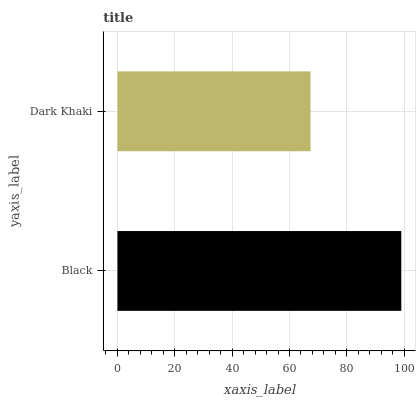Is Dark Khaki the minimum?
Answer yes or no. Yes. Is Black the maximum?
Answer yes or no. Yes. Is Dark Khaki the maximum?
Answer yes or no. No. Is Black greater than Dark Khaki?
Answer yes or no. Yes. Is Dark Khaki less than Black?
Answer yes or no. Yes. Is Dark Khaki greater than Black?
Answer yes or no. No. Is Black less than Dark Khaki?
Answer yes or no. No. Is Black the high median?
Answer yes or no. Yes. Is Dark Khaki the low median?
Answer yes or no. Yes. Is Dark Khaki the high median?
Answer yes or no. No. Is Black the low median?
Answer yes or no. No. 